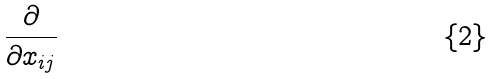<formula> <loc_0><loc_0><loc_500><loc_500>\frac { \partial } { \partial x _ { i j } }</formula> 